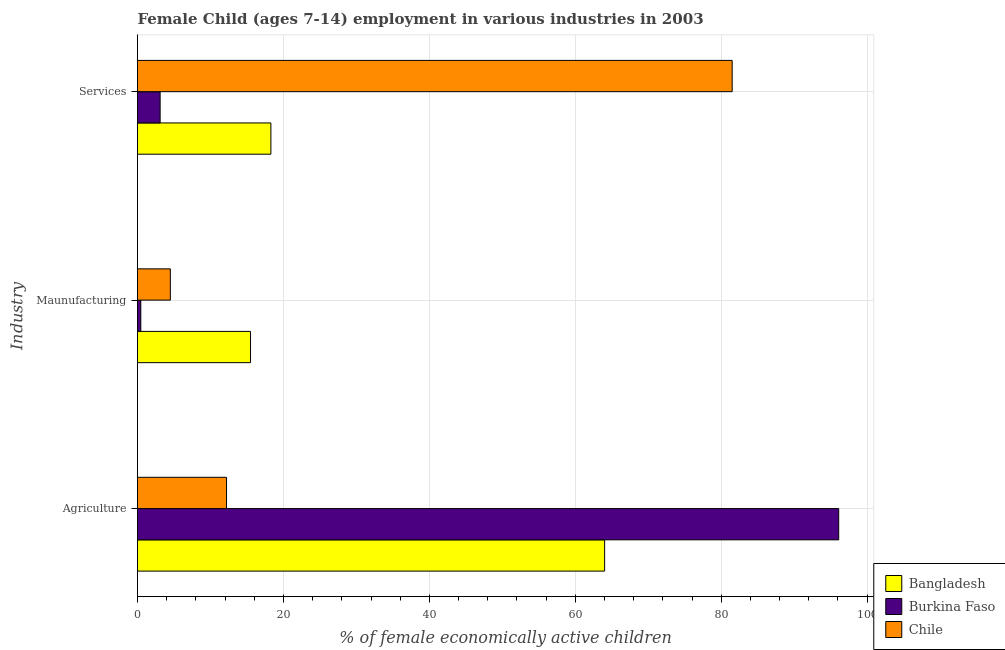How many different coloured bars are there?
Ensure brevity in your answer.  3. How many groups of bars are there?
Ensure brevity in your answer.  3. How many bars are there on the 3rd tick from the bottom?
Keep it short and to the point. 3. What is the label of the 2nd group of bars from the top?
Offer a very short reply. Maunufacturing. What is the percentage of economically active children in agriculture in Burkina Faso?
Ensure brevity in your answer.  96.1. Across all countries, what is the maximum percentage of economically active children in services?
Provide a succinct answer. 81.5. In which country was the percentage of economically active children in agriculture maximum?
Your answer should be very brief. Burkina Faso. In which country was the percentage of economically active children in agriculture minimum?
Offer a terse response. Chile. What is the total percentage of economically active children in services in the graph?
Give a very brief answer. 102.88. What is the difference between the percentage of economically active children in manufacturing in Bangladesh and that in Burkina Faso?
Give a very brief answer. 15.04. What is the difference between the percentage of economically active children in manufacturing in Bangladesh and the percentage of economically active children in services in Chile?
Give a very brief answer. -66.01. What is the average percentage of economically active children in manufacturing per country?
Give a very brief answer. 6.81. What is the difference between the percentage of economically active children in agriculture and percentage of economically active children in services in Chile?
Give a very brief answer. -69.3. In how many countries, is the percentage of economically active children in services greater than 20 %?
Offer a terse response. 1. What is the ratio of the percentage of economically active children in services in Burkina Faso to that in Bangladesh?
Your answer should be compact. 0.17. What is the difference between the highest and the second highest percentage of economically active children in manufacturing?
Offer a very short reply. 10.99. What is the difference between the highest and the lowest percentage of economically active children in services?
Provide a short and direct response. 78.4. In how many countries, is the percentage of economically active children in agriculture greater than the average percentage of economically active children in agriculture taken over all countries?
Offer a very short reply. 2. Is the sum of the percentage of economically active children in services in Burkina Faso and Chile greater than the maximum percentage of economically active children in manufacturing across all countries?
Provide a succinct answer. Yes. What does the 1st bar from the top in Services represents?
Ensure brevity in your answer.  Chile. What does the 2nd bar from the bottom in Maunufacturing represents?
Ensure brevity in your answer.  Burkina Faso. Are all the bars in the graph horizontal?
Provide a short and direct response. Yes. How many countries are there in the graph?
Your answer should be compact. 3. What is the difference between two consecutive major ticks on the X-axis?
Give a very brief answer. 20. Are the values on the major ticks of X-axis written in scientific E-notation?
Your answer should be very brief. No. Does the graph contain grids?
Offer a very short reply. Yes. Where does the legend appear in the graph?
Your answer should be very brief. Bottom right. How many legend labels are there?
Keep it short and to the point. 3. How are the legend labels stacked?
Provide a succinct answer. Vertical. What is the title of the graph?
Offer a terse response. Female Child (ages 7-14) employment in various industries in 2003. Does "Jamaica" appear as one of the legend labels in the graph?
Provide a succinct answer. No. What is the label or title of the X-axis?
Keep it short and to the point. % of female economically active children. What is the label or title of the Y-axis?
Provide a short and direct response. Industry. What is the % of female economically active children in Bangladesh in Agriculture?
Provide a succinct answer. 64.02. What is the % of female economically active children of Burkina Faso in Agriculture?
Your answer should be very brief. 96.1. What is the % of female economically active children in Bangladesh in Maunufacturing?
Keep it short and to the point. 15.49. What is the % of female economically active children in Burkina Faso in Maunufacturing?
Offer a terse response. 0.45. What is the % of female economically active children in Chile in Maunufacturing?
Make the answer very short. 4.5. What is the % of female economically active children in Bangladesh in Services?
Offer a terse response. 18.28. What is the % of female economically active children of Chile in Services?
Keep it short and to the point. 81.5. Across all Industry, what is the maximum % of female economically active children of Bangladesh?
Keep it short and to the point. 64.02. Across all Industry, what is the maximum % of female economically active children of Burkina Faso?
Make the answer very short. 96.1. Across all Industry, what is the maximum % of female economically active children of Chile?
Offer a terse response. 81.5. Across all Industry, what is the minimum % of female economically active children of Bangladesh?
Ensure brevity in your answer.  15.49. Across all Industry, what is the minimum % of female economically active children in Burkina Faso?
Your answer should be very brief. 0.45. What is the total % of female economically active children in Bangladesh in the graph?
Provide a short and direct response. 97.79. What is the total % of female economically active children in Burkina Faso in the graph?
Make the answer very short. 99.65. What is the total % of female economically active children in Chile in the graph?
Your response must be concise. 98.2. What is the difference between the % of female economically active children of Bangladesh in Agriculture and that in Maunufacturing?
Ensure brevity in your answer.  48.53. What is the difference between the % of female economically active children of Burkina Faso in Agriculture and that in Maunufacturing?
Make the answer very short. 95.65. What is the difference between the % of female economically active children of Chile in Agriculture and that in Maunufacturing?
Keep it short and to the point. 7.7. What is the difference between the % of female economically active children in Bangladesh in Agriculture and that in Services?
Give a very brief answer. 45.74. What is the difference between the % of female economically active children of Burkina Faso in Agriculture and that in Services?
Provide a succinct answer. 93. What is the difference between the % of female economically active children in Chile in Agriculture and that in Services?
Give a very brief answer. -69.3. What is the difference between the % of female economically active children of Bangladesh in Maunufacturing and that in Services?
Your answer should be very brief. -2.79. What is the difference between the % of female economically active children of Burkina Faso in Maunufacturing and that in Services?
Provide a succinct answer. -2.65. What is the difference between the % of female economically active children in Chile in Maunufacturing and that in Services?
Your answer should be compact. -77. What is the difference between the % of female economically active children of Bangladesh in Agriculture and the % of female economically active children of Burkina Faso in Maunufacturing?
Offer a terse response. 63.57. What is the difference between the % of female economically active children in Bangladesh in Agriculture and the % of female economically active children in Chile in Maunufacturing?
Provide a succinct answer. 59.52. What is the difference between the % of female economically active children in Burkina Faso in Agriculture and the % of female economically active children in Chile in Maunufacturing?
Your answer should be very brief. 91.6. What is the difference between the % of female economically active children in Bangladesh in Agriculture and the % of female economically active children in Burkina Faso in Services?
Provide a short and direct response. 60.92. What is the difference between the % of female economically active children of Bangladesh in Agriculture and the % of female economically active children of Chile in Services?
Keep it short and to the point. -17.48. What is the difference between the % of female economically active children in Burkina Faso in Agriculture and the % of female economically active children in Chile in Services?
Your response must be concise. 14.6. What is the difference between the % of female economically active children of Bangladesh in Maunufacturing and the % of female economically active children of Burkina Faso in Services?
Keep it short and to the point. 12.39. What is the difference between the % of female economically active children of Bangladesh in Maunufacturing and the % of female economically active children of Chile in Services?
Make the answer very short. -66.01. What is the difference between the % of female economically active children of Burkina Faso in Maunufacturing and the % of female economically active children of Chile in Services?
Your answer should be very brief. -81.05. What is the average % of female economically active children in Bangladesh per Industry?
Your response must be concise. 32.6. What is the average % of female economically active children of Burkina Faso per Industry?
Your answer should be very brief. 33.22. What is the average % of female economically active children of Chile per Industry?
Offer a very short reply. 32.73. What is the difference between the % of female economically active children of Bangladesh and % of female economically active children of Burkina Faso in Agriculture?
Your answer should be compact. -32.08. What is the difference between the % of female economically active children of Bangladesh and % of female economically active children of Chile in Agriculture?
Your answer should be very brief. 51.82. What is the difference between the % of female economically active children of Burkina Faso and % of female economically active children of Chile in Agriculture?
Provide a short and direct response. 83.9. What is the difference between the % of female economically active children of Bangladesh and % of female economically active children of Burkina Faso in Maunufacturing?
Offer a very short reply. 15.04. What is the difference between the % of female economically active children in Bangladesh and % of female economically active children in Chile in Maunufacturing?
Provide a succinct answer. 10.99. What is the difference between the % of female economically active children in Burkina Faso and % of female economically active children in Chile in Maunufacturing?
Offer a terse response. -4.05. What is the difference between the % of female economically active children in Bangladesh and % of female economically active children in Burkina Faso in Services?
Offer a terse response. 15.18. What is the difference between the % of female economically active children in Bangladesh and % of female economically active children in Chile in Services?
Ensure brevity in your answer.  -63.22. What is the difference between the % of female economically active children in Burkina Faso and % of female economically active children in Chile in Services?
Give a very brief answer. -78.4. What is the ratio of the % of female economically active children in Bangladesh in Agriculture to that in Maunufacturing?
Your answer should be compact. 4.13. What is the ratio of the % of female economically active children of Burkina Faso in Agriculture to that in Maunufacturing?
Provide a short and direct response. 213.2. What is the ratio of the % of female economically active children of Chile in Agriculture to that in Maunufacturing?
Provide a succinct answer. 2.71. What is the ratio of the % of female economically active children in Bangladesh in Agriculture to that in Services?
Your answer should be compact. 3.5. What is the ratio of the % of female economically active children in Burkina Faso in Agriculture to that in Services?
Your response must be concise. 31. What is the ratio of the % of female economically active children in Chile in Agriculture to that in Services?
Offer a terse response. 0.15. What is the ratio of the % of female economically active children of Bangladesh in Maunufacturing to that in Services?
Ensure brevity in your answer.  0.85. What is the ratio of the % of female economically active children in Burkina Faso in Maunufacturing to that in Services?
Offer a terse response. 0.15. What is the ratio of the % of female economically active children of Chile in Maunufacturing to that in Services?
Ensure brevity in your answer.  0.06. What is the difference between the highest and the second highest % of female economically active children in Bangladesh?
Your answer should be compact. 45.74. What is the difference between the highest and the second highest % of female economically active children of Burkina Faso?
Give a very brief answer. 93. What is the difference between the highest and the second highest % of female economically active children in Chile?
Your answer should be compact. 69.3. What is the difference between the highest and the lowest % of female economically active children in Bangladesh?
Provide a succinct answer. 48.53. What is the difference between the highest and the lowest % of female economically active children of Burkina Faso?
Your response must be concise. 95.65. What is the difference between the highest and the lowest % of female economically active children in Chile?
Your answer should be compact. 77. 